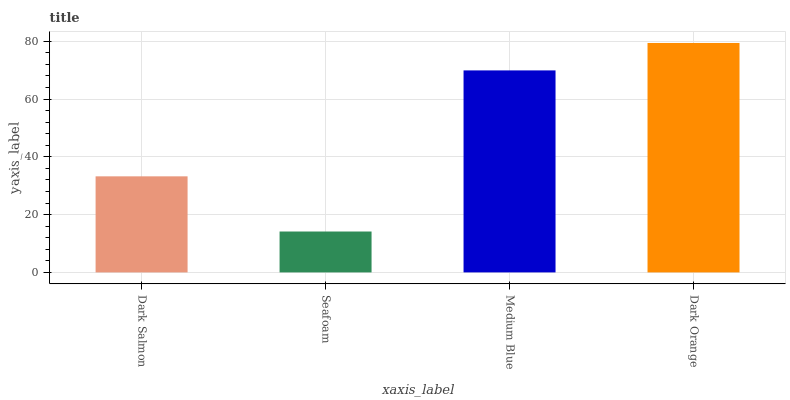Is Seafoam the minimum?
Answer yes or no. Yes. Is Dark Orange the maximum?
Answer yes or no. Yes. Is Medium Blue the minimum?
Answer yes or no. No. Is Medium Blue the maximum?
Answer yes or no. No. Is Medium Blue greater than Seafoam?
Answer yes or no. Yes. Is Seafoam less than Medium Blue?
Answer yes or no. Yes. Is Seafoam greater than Medium Blue?
Answer yes or no. No. Is Medium Blue less than Seafoam?
Answer yes or no. No. Is Medium Blue the high median?
Answer yes or no. Yes. Is Dark Salmon the low median?
Answer yes or no. Yes. Is Dark Orange the high median?
Answer yes or no. No. Is Dark Orange the low median?
Answer yes or no. No. 